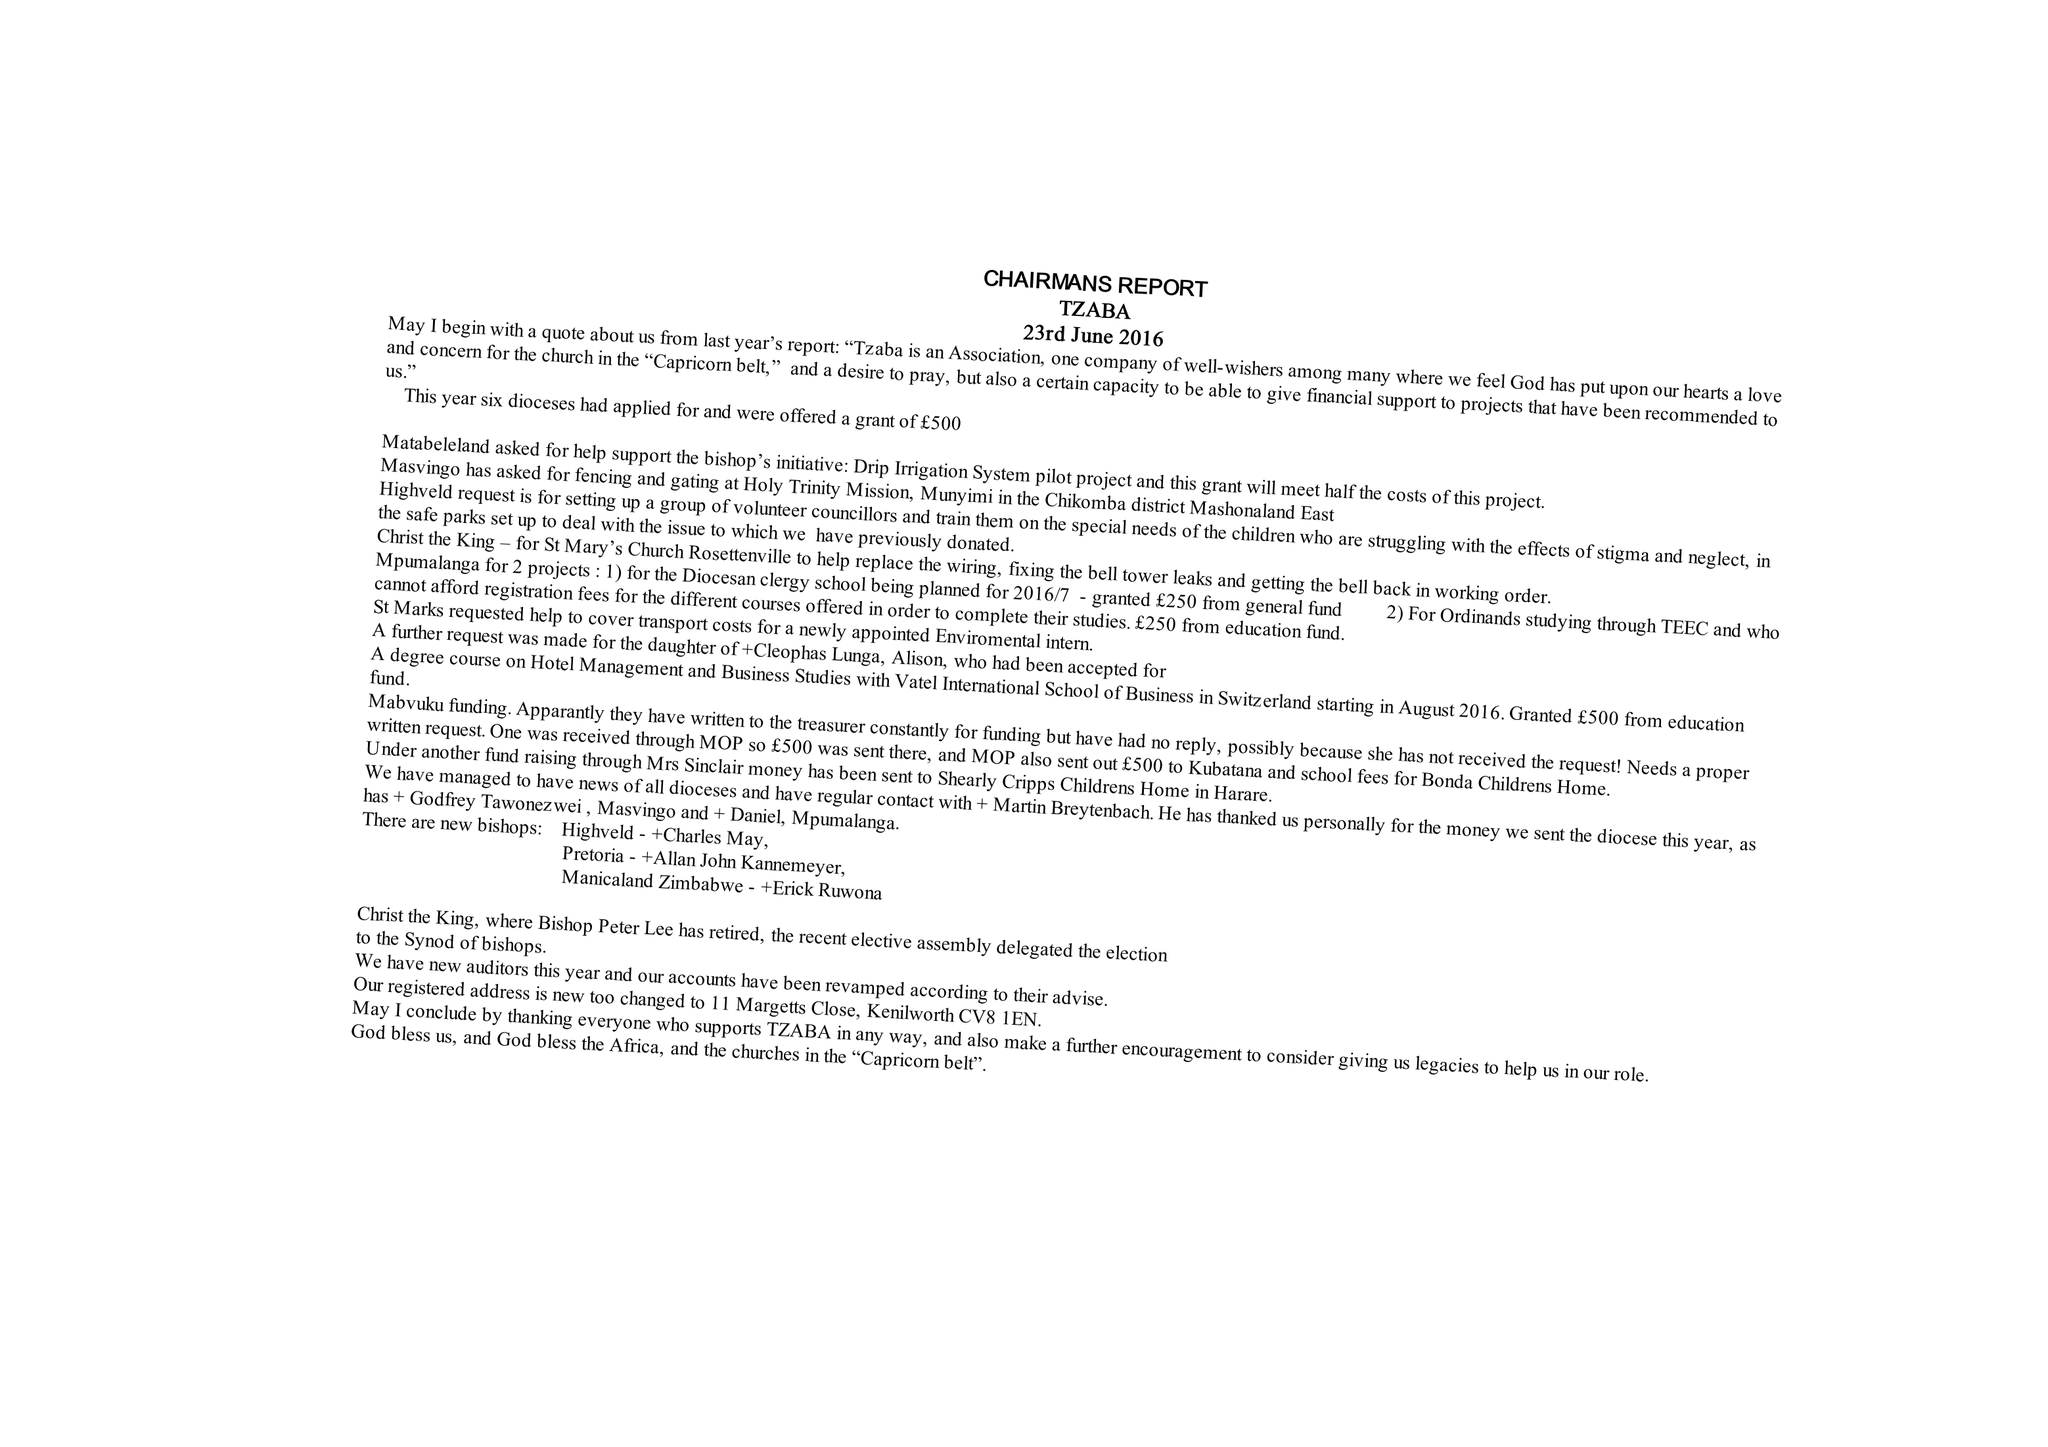What is the value for the address__postcode?
Answer the question using a single word or phrase. CV8 1EN 